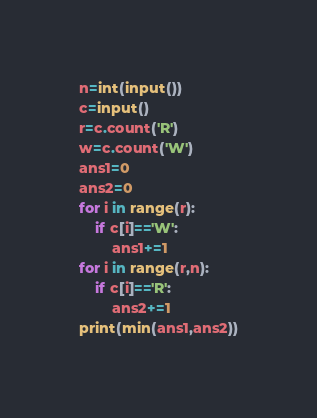<code> <loc_0><loc_0><loc_500><loc_500><_Python_>n=int(input())
c=input()
r=c.count('R')
w=c.count('W')
ans1=0
ans2=0
for i in range(r):
    if c[i]=='W':
        ans1+=1
for i in range(r,n):
    if c[i]=='R':
        ans2+=1
print(min(ans1,ans2))</code> 